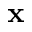Convert formula to latex. <formula><loc_0><loc_0><loc_500><loc_500>x</formula> 